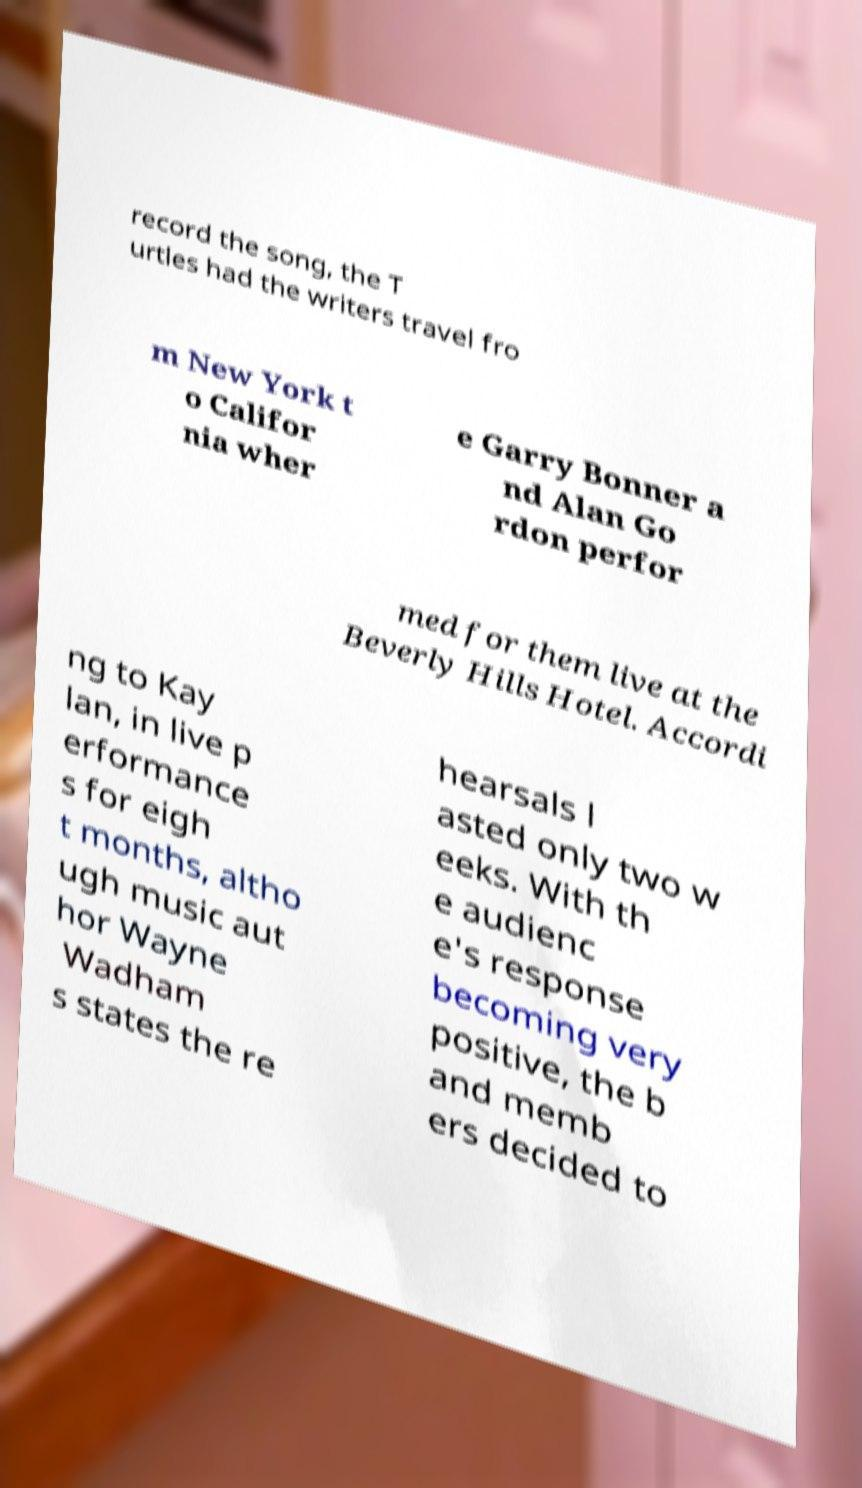Can you read and provide the text displayed in the image?This photo seems to have some interesting text. Can you extract and type it out for me? record the song, the T urtles had the writers travel fro m New York t o Califor nia wher e Garry Bonner a nd Alan Go rdon perfor med for them live at the Beverly Hills Hotel. Accordi ng to Kay lan, in live p erformance s for eigh t months, altho ugh music aut hor Wayne Wadham s states the re hearsals l asted only two w eeks. With th e audienc e's response becoming very positive, the b and memb ers decided to 